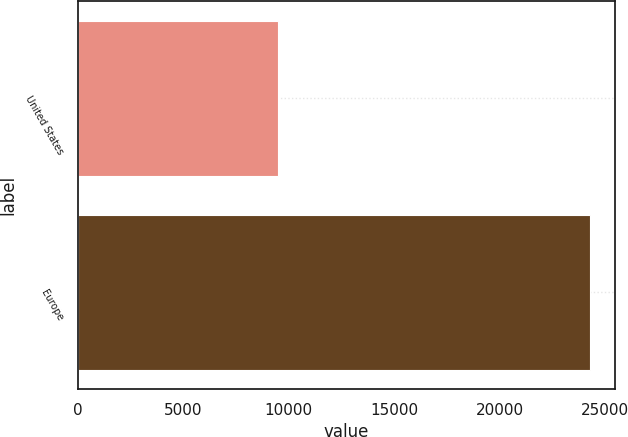Convert chart. <chart><loc_0><loc_0><loc_500><loc_500><bar_chart><fcel>United States<fcel>Europe<nl><fcel>9485<fcel>24255<nl></chart> 